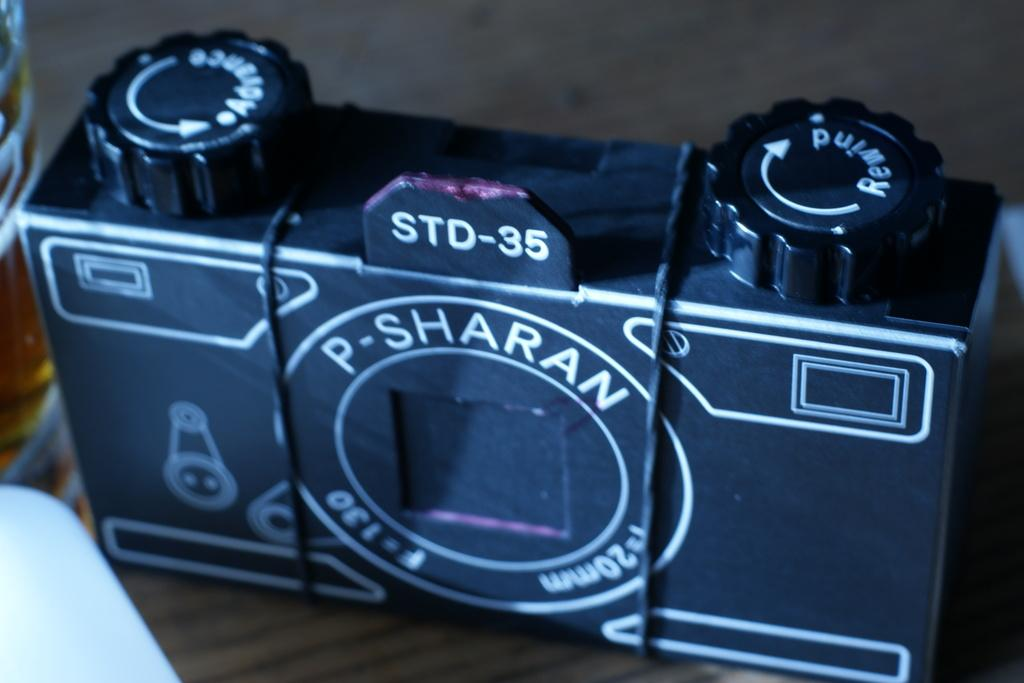<image>
Give a short and clear explanation of the subsequent image. a camera that has the word sharan on it 